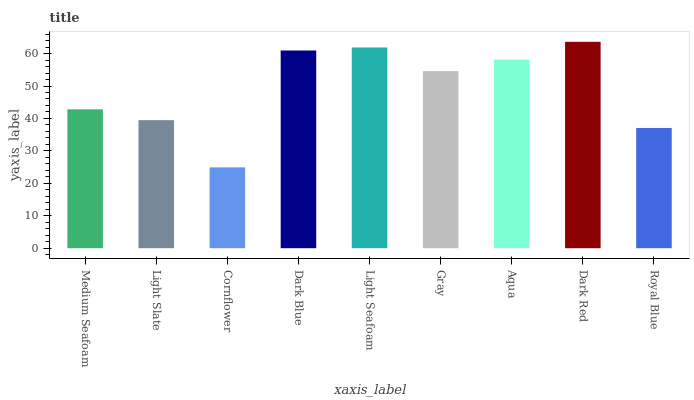Is Cornflower the minimum?
Answer yes or no. Yes. Is Dark Red the maximum?
Answer yes or no. Yes. Is Light Slate the minimum?
Answer yes or no. No. Is Light Slate the maximum?
Answer yes or no. No. Is Medium Seafoam greater than Light Slate?
Answer yes or no. Yes. Is Light Slate less than Medium Seafoam?
Answer yes or no. Yes. Is Light Slate greater than Medium Seafoam?
Answer yes or no. No. Is Medium Seafoam less than Light Slate?
Answer yes or no. No. Is Gray the high median?
Answer yes or no. Yes. Is Gray the low median?
Answer yes or no. Yes. Is Aqua the high median?
Answer yes or no. No. Is Medium Seafoam the low median?
Answer yes or no. No. 